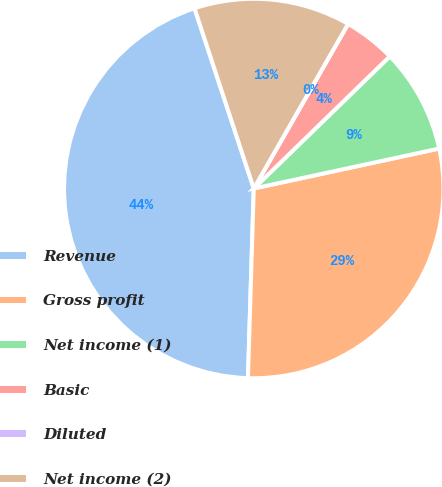Convert chart. <chart><loc_0><loc_0><loc_500><loc_500><pie_chart><fcel>Revenue<fcel>Gross profit<fcel>Net income (1)<fcel>Basic<fcel>Diluted<fcel>Net income (2)<nl><fcel>44.46%<fcel>28.87%<fcel>8.89%<fcel>4.45%<fcel>0.0%<fcel>13.34%<nl></chart> 